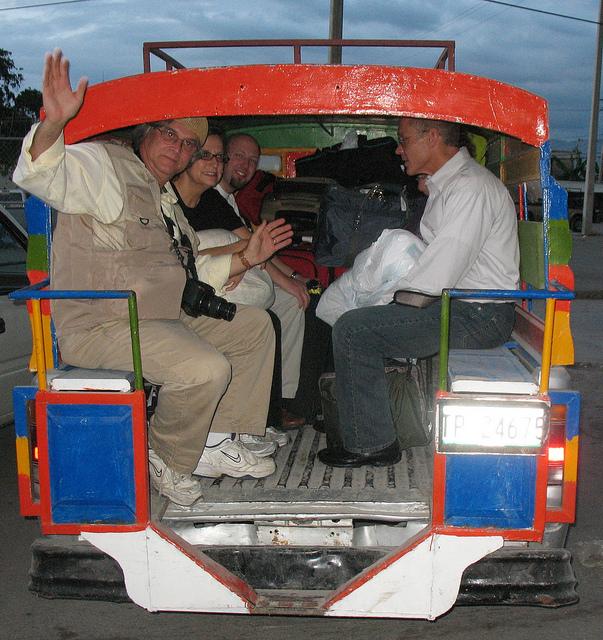How many people are in the vehicle?
Concise answer only. 5. Is this scene an advertisement for the new transformers movie?
Keep it brief. No. Is there a man waving at the camera?
Concise answer only. Yes. 